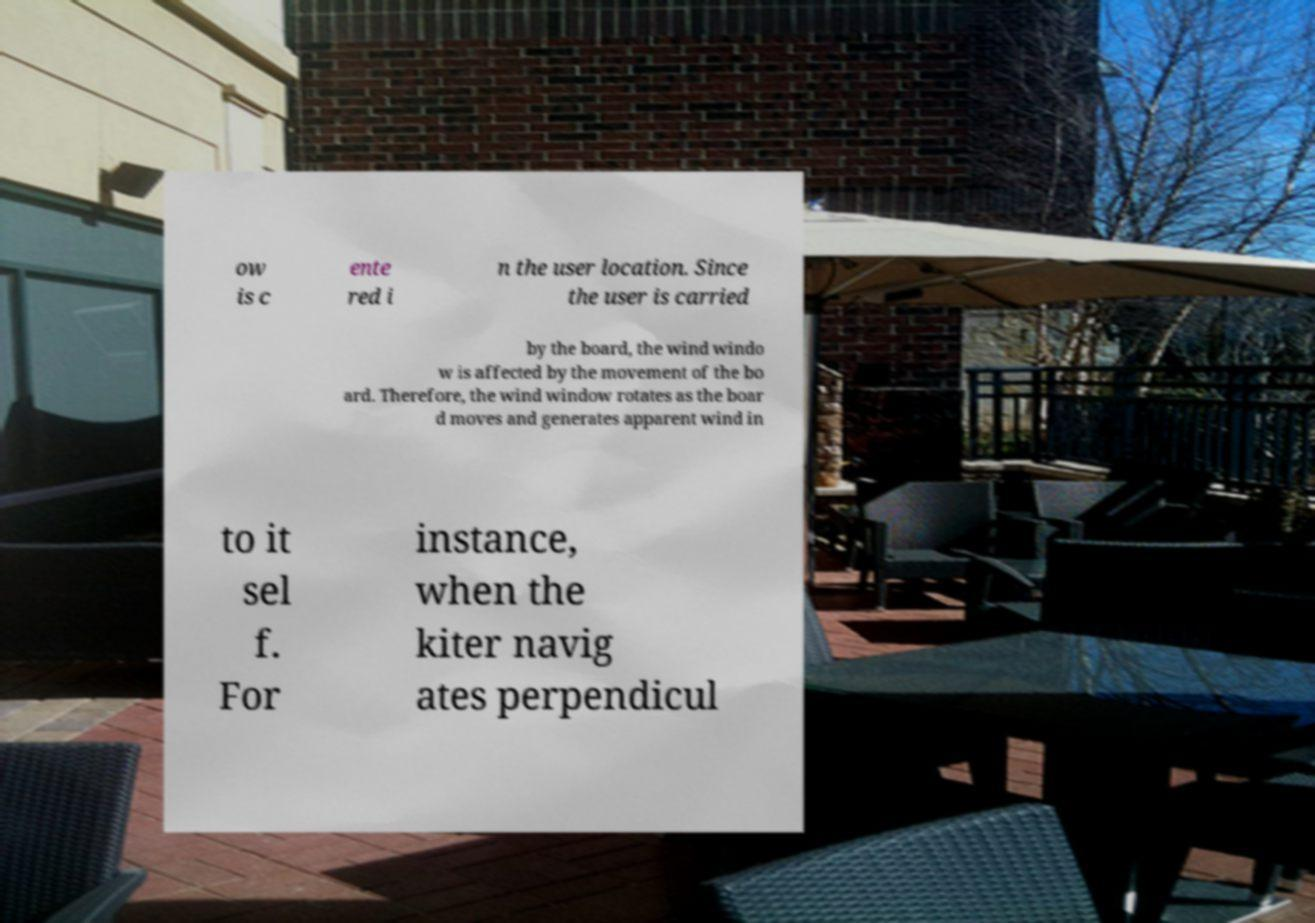There's text embedded in this image that I need extracted. Can you transcribe it verbatim? ow is c ente red i n the user location. Since the user is carried by the board, the wind windo w is affected by the movement of the bo ard. Therefore, the wind window rotates as the boar d moves and generates apparent wind in to it sel f. For instance, when the kiter navig ates perpendicul 